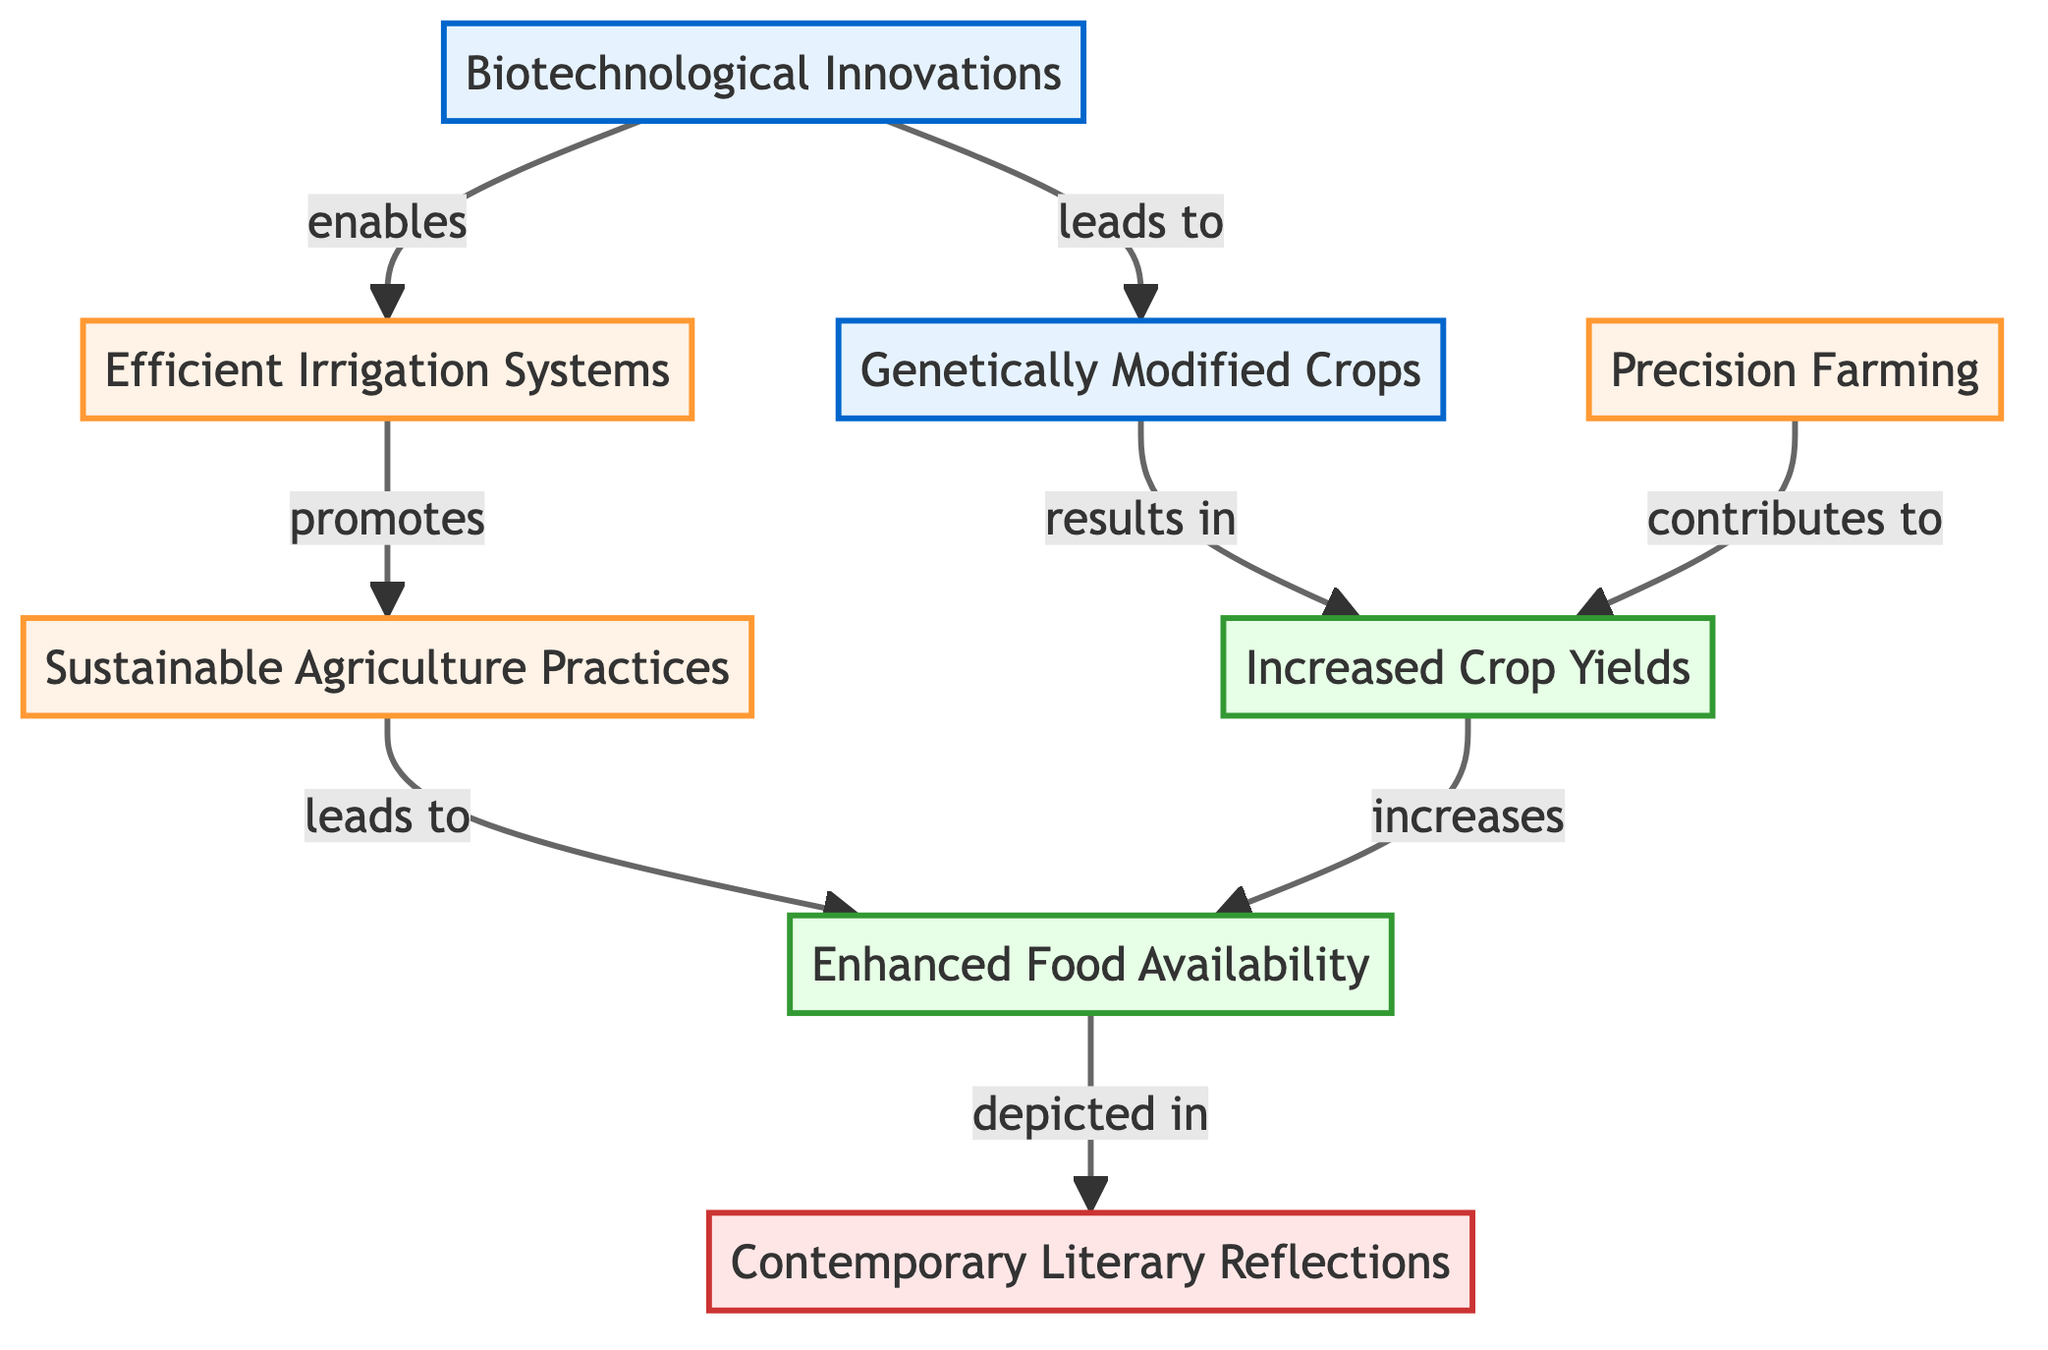What is the first node in the diagram? The first node listed in the diagram is "Biotechnological Innovations." It is the starting point from which the rest of the food chain evolves.
Answer: Biotechnological Innovations How many nodes are in the diagram? Counting all the distinct nodes in the diagram, we find eight nodes representing various stages of the food chain related to agricultural processes and literature.
Answer: 8 What is the relationship between "Genetically Modified Crops" and "Increased Crop Yields"? The diagram indicates that "Genetically Modified Crops" results in "Increased Crop Yields," establishing a direct cause-and-effect relationship between these two nodes.
Answer: results in Which node contributes to both "Increased Crop Yields" and "Efficient Irrigation Systems"? "Precision Farming" contributes to "Increased Crop Yields" and is also not a direct cause for "Efficient Irrigation Systems," so the focus here is the direct connection between the nodes, which is seen in "Biotechnological Innovations," enabling "Efficient Irrigation Systems."
Answer: Biotechnological Innovations What leads to "Enhanced Food Availability"? The diagram shows that "Sustainable Agriculture Practices" leads to "Enhanced Food Availability." This relationship illustrates how implementing sustainable practices enhances the overall availability of food resources.
Answer: leads to Why is "Contemporary Literary Reflections" a significant node? "Contemporary Literary Reflections" signifies how all the ideas and processes represented in the food chain are depicted in literature, showing an intersection between technological advancements in agriculture and their reflection in contemporary writing.
Answer: significant What promotes "Sustainable Agriculture Practices"? The diagram states that "Efficient Irrigation Systems" promotes "Sustainable Agriculture Practices," indicating that improvements in irrigation directly support sustainable farming methods.
Answer: promotes How many edges are connecting the nodes in the diagram? To determine the number of edges, one needs to count the directional connections between all nodes, and by tracing the connections, we find there are seven edges in total.
Answer: 7 Which innovations lead to "Enhanced Food Availability"? "Increased Crop Yields" and "Sustainable Agriculture Practices" are both the innovations that contribute to "Enhanced Food Availability,” indicating they are crucial for improving the food supply.
Answer: Increased Crop Yields, Sustainable Agriculture Practices 